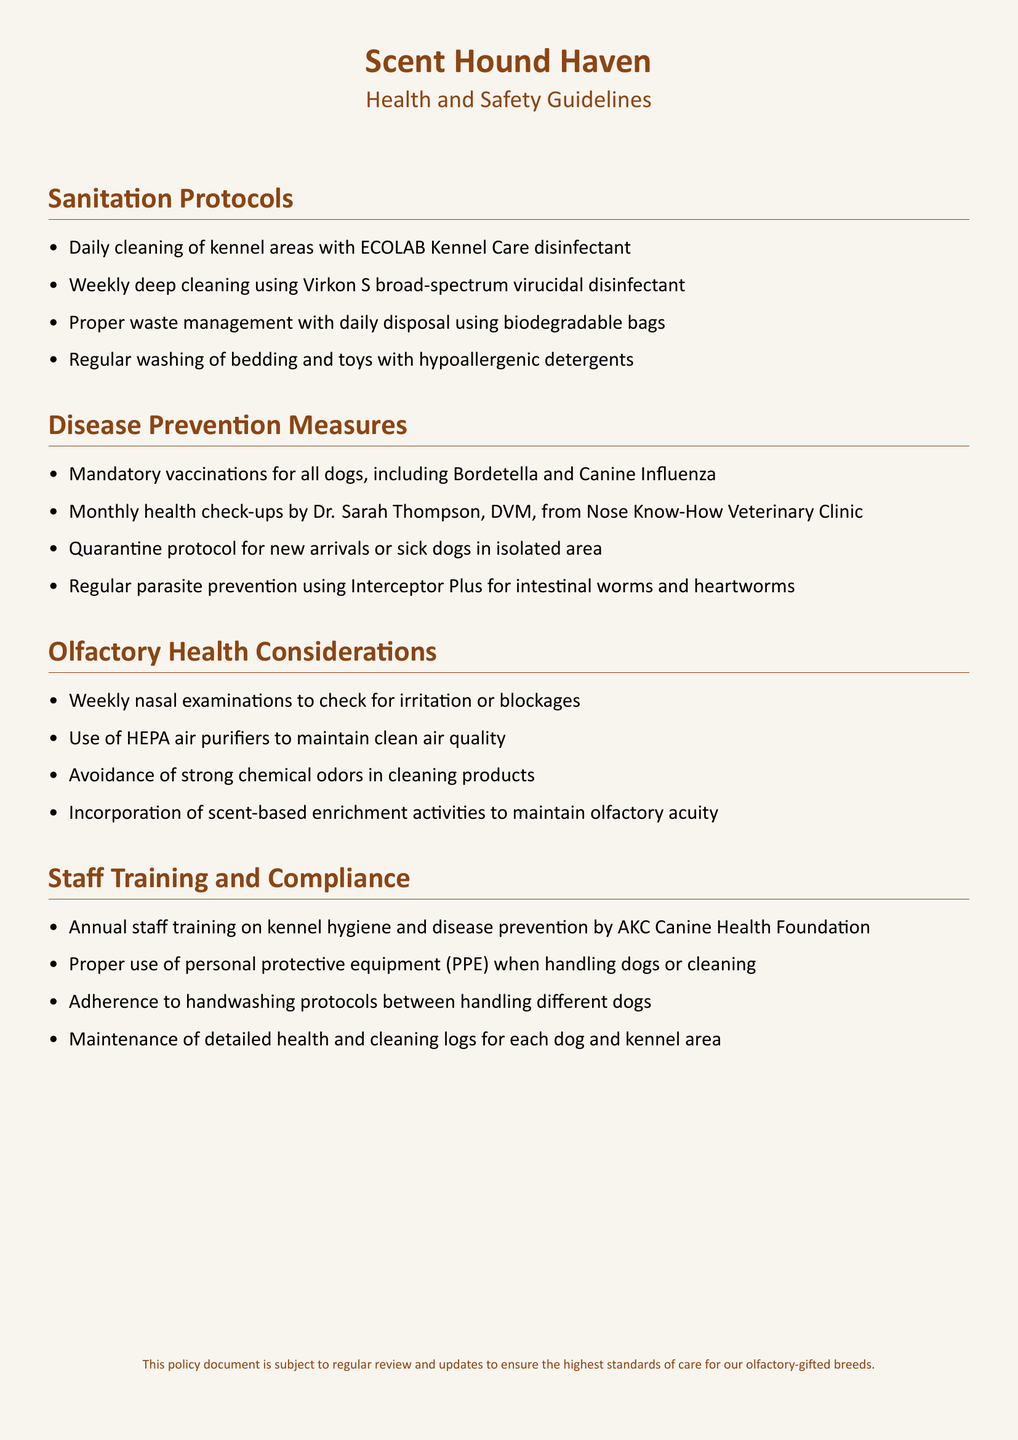What disinfectant is used for daily cleaning? The document states that ECOLAB Kennel Care disinfectant is used for daily cleaning of kennel areas.
Answer: ECOLAB Kennel Care disinfectant Who conducts monthly health check-ups? The monthly health check-ups are conducted by Dr. Sarah Thompson from Nose Know-How Veterinary Clinic.
Answer: Dr. Sarah Thompson What is the quarantine protocol for? The quarantine protocol is for new arrivals or sick dogs in isolated areas.
Answer: New arrivals or sick dogs What is used for regular parasite prevention? The document mentions the use of Interceptor Plus for intestinal worms and heartworms for regular parasite prevention.
Answer: Interceptor Plus How often are nasal examinations conducted? The document states that nasal examinations are conducted weekly to check for irritation or blockages.
Answer: Weekly What type of air purifiers is used? The document specifies the use of HEPA air purifiers to maintain clean air quality.
Answer: HEPA air purifiers How often does staff training occur? Annual staff training on kennel hygiene and disease prevention is required as per the document.
Answer: Annual What is maintained for each dog and kennel area? The document mentions maintaining detailed health and cleaning logs for each dog and kennel area.
Answer: Health and cleaning logs 